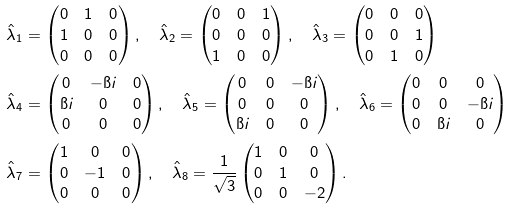<formula> <loc_0><loc_0><loc_500><loc_500>& \hat { \lambda } _ { 1 } = \begin{pmatrix} 0 & 1 & 0 \\ 1 & 0 & 0 \\ 0 & 0 & 0 \end{pmatrix} , \quad \hat { \lambda } _ { 2 } = \begin{pmatrix} 0 & 0 & 1 \\ 0 & 0 & 0 \\ 1 & 0 & 0 \end{pmatrix} , \quad \hat { \lambda } _ { 3 } = \begin{pmatrix} 0 & 0 & 0 \\ 0 & 0 & 1 \\ 0 & 1 & 0 \end{pmatrix} \\ & \hat { \lambda } _ { 4 } = \begin{pmatrix} 0 & - \i i & 0 \\ \i i & 0 & 0 \\ 0 & 0 & 0 \end{pmatrix} , \quad \hat { \lambda } _ { 5 } = \begin{pmatrix} 0 & 0 & - \i i \\ 0 & 0 & 0 \\ \i i & 0 & 0 \end{pmatrix} , \quad \hat { \lambda } _ { 6 } = \begin{pmatrix} 0 & 0 & 0 \\ 0 & 0 & - \i i \\ 0 & \i i & 0 \end{pmatrix} \\ & \hat { \lambda } _ { 7 } = \begin{pmatrix} 1 & 0 & 0 \\ 0 & - 1 & 0 \\ 0 & 0 & 0 \end{pmatrix} , \quad \hat { \lambda } _ { 8 } = \frac { 1 } { \sqrt { 3 } } \begin{pmatrix} 1 & 0 & 0 \\ 0 & 1 & 0 \\ 0 & 0 & - 2 \end{pmatrix} .</formula> 